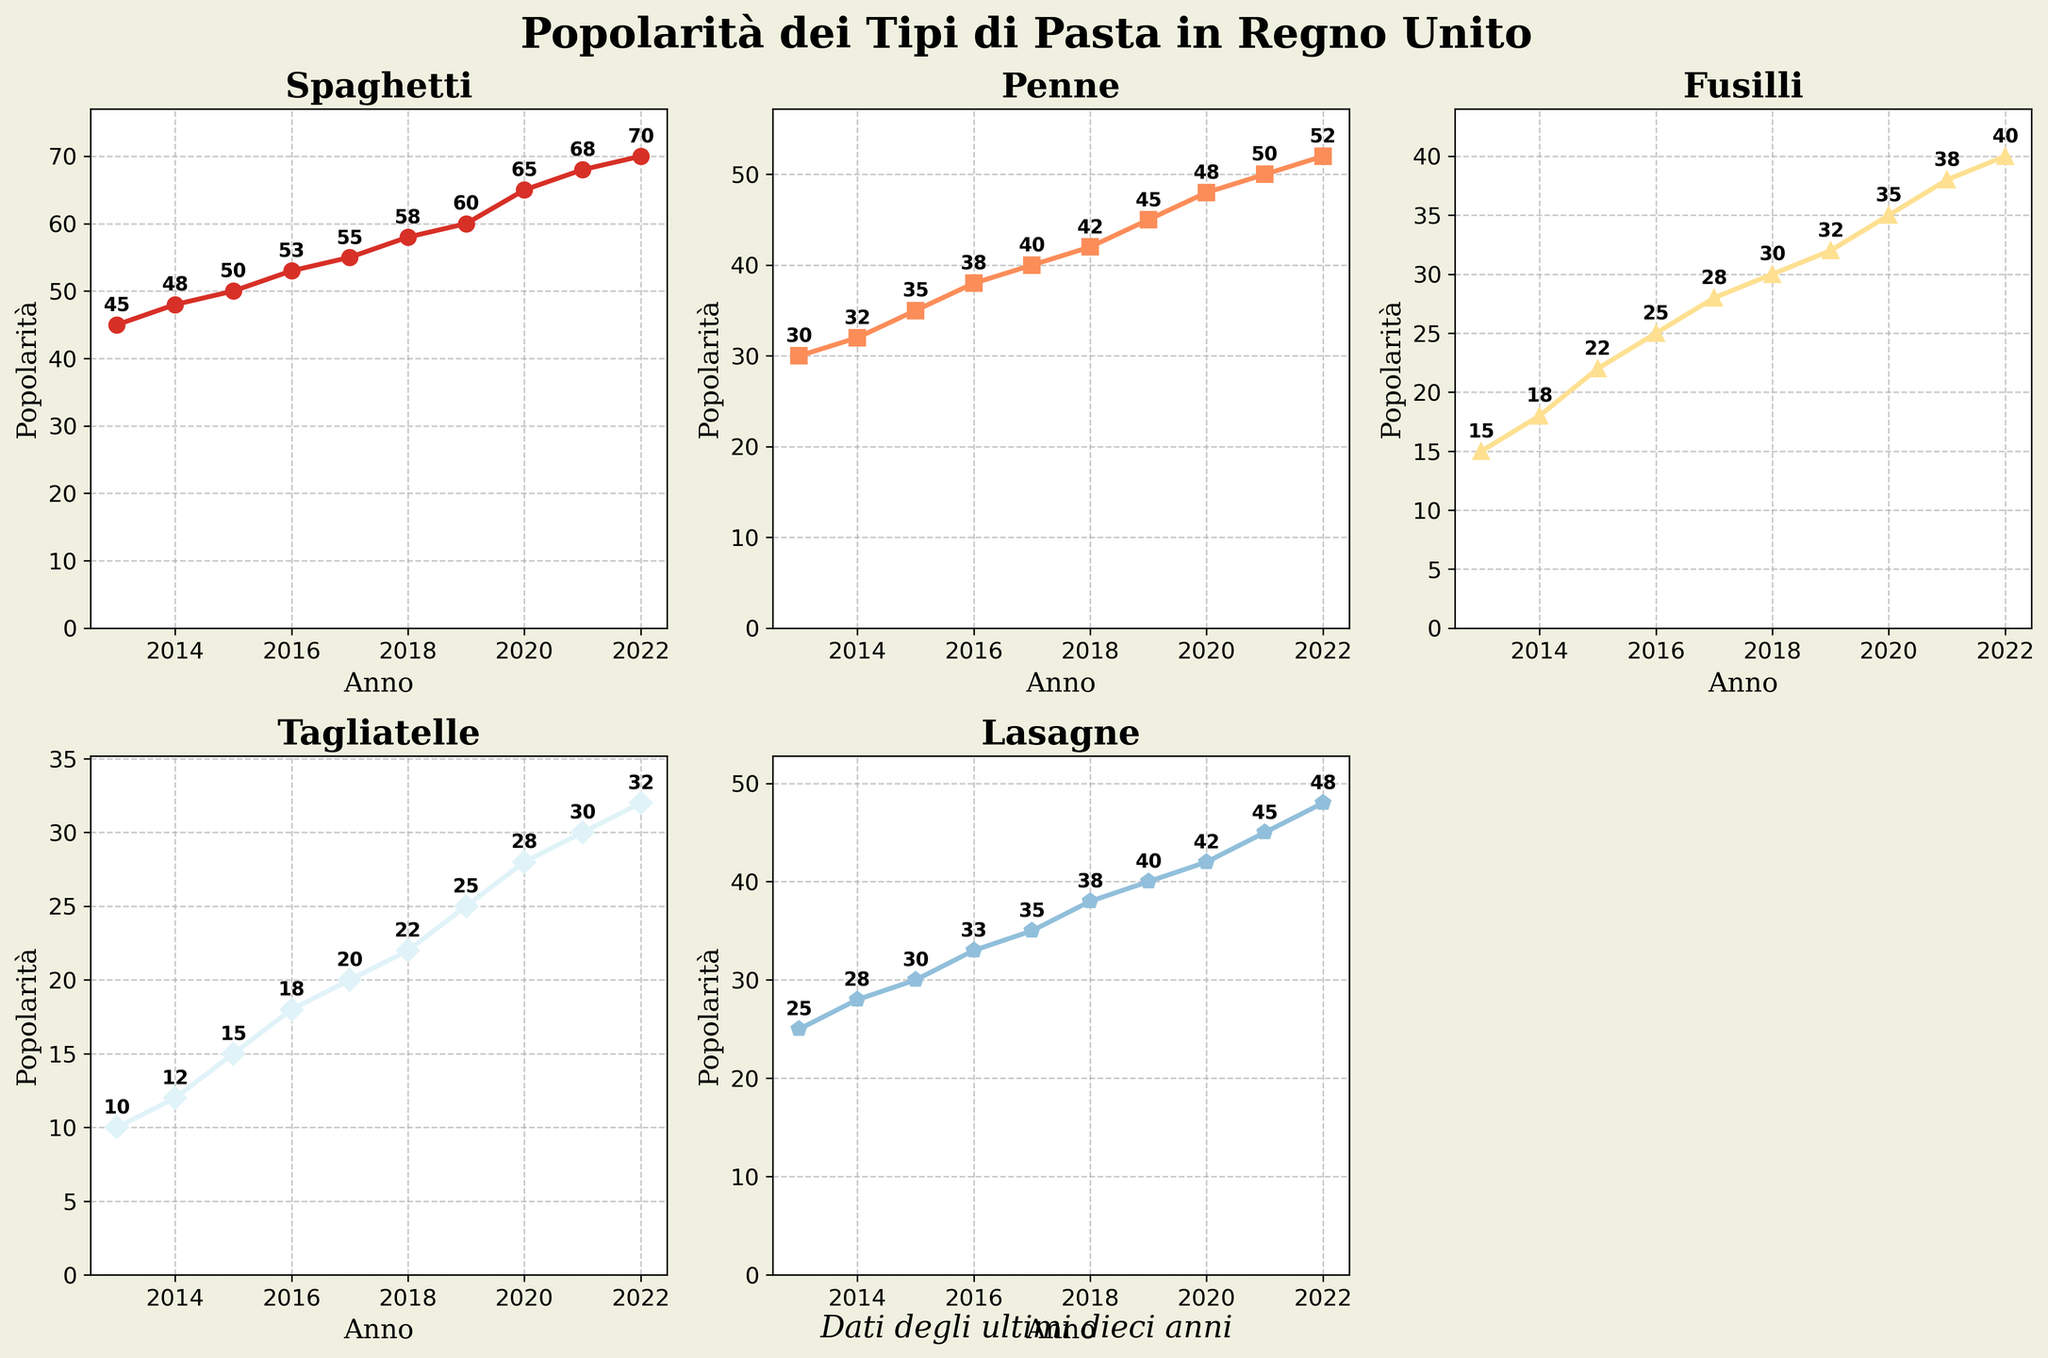Which type of pasta has the highest popularity in 2022? By inspecting the last data point on each line in the subplots, we see that Spaghetti has the highest value at 70.
Answer: Spaghetti What is the trend of Tagliatelle's popularity over the years? Observing the Tagliatelle subplot, we see a consistent rise in popularity from 10 in 2013 to 32 in 2022.
Answer: Increasing How does the popularity of Penne in 2016 compare to its popularity in 2020? In the Penne subplot, Penne's popularity is at 38 in 2016 and rises to 48 in 2020.
Answer: 2020 is higher Which year did Lasagne's popularity first reach 40? Checking the Lasagne subplot, Lasagne reached the popularity of 40 in the year 2019.
Answer: 2019 What was the average popularity of Fusilli over the decade? Adding all the point values for Fusilli (15, 18, 22, 25, 28, 30, 32, 35, 38, 40) and dividing by the number of years (10) gives (15+18+22+25+28+30+32+35+38+40)/10 = 28.3
Answer: 28.3 Between which two years did Spaghetti see the highest increase in popularity? From the Spaghetti subplot, the biggest increase is from 60 in 2019 to 65 in 2020, an increase of 5.
Answer: 2019-2020 Which type of pasta had the least overall popularity growth over the decade? Calculating the growth for each type: Spaghetti (70-45=25), Penne (52-30=22), Fusilli (40-15=25), Tagliatelle (32-10=22), and Lasagne (48-25=23), we observe Penne and Tagliatelle had the least growth of 22.
Answer: Penne, Tagliatelle What is the total combined popularity of all pasta types in 2018? Adding all the popularity values in 2018 (58 + 42 + 30 + 22 + 38) = 190.
Answer: 190 In which year did Fusilli's popularity surpass 30 for the first time? Inspecting the Fusilli subplot, Fusilli's popularity first surpasses 30 in the year 2018.
Answer: 2018 How much more popular was Lasagne compared to Tagliatelle in 2022? Lasagne's popularity in 2022 is 48 and Tagliatelle's is 32; the difference is 48 - 32 = 16.
Answer: 16 